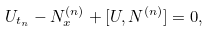Convert formula to latex. <formula><loc_0><loc_0><loc_500><loc_500>U _ { t _ { n } } - N ^ { ( n ) } _ { x } + [ U , N ^ { ( n ) } ] = 0 ,</formula> 